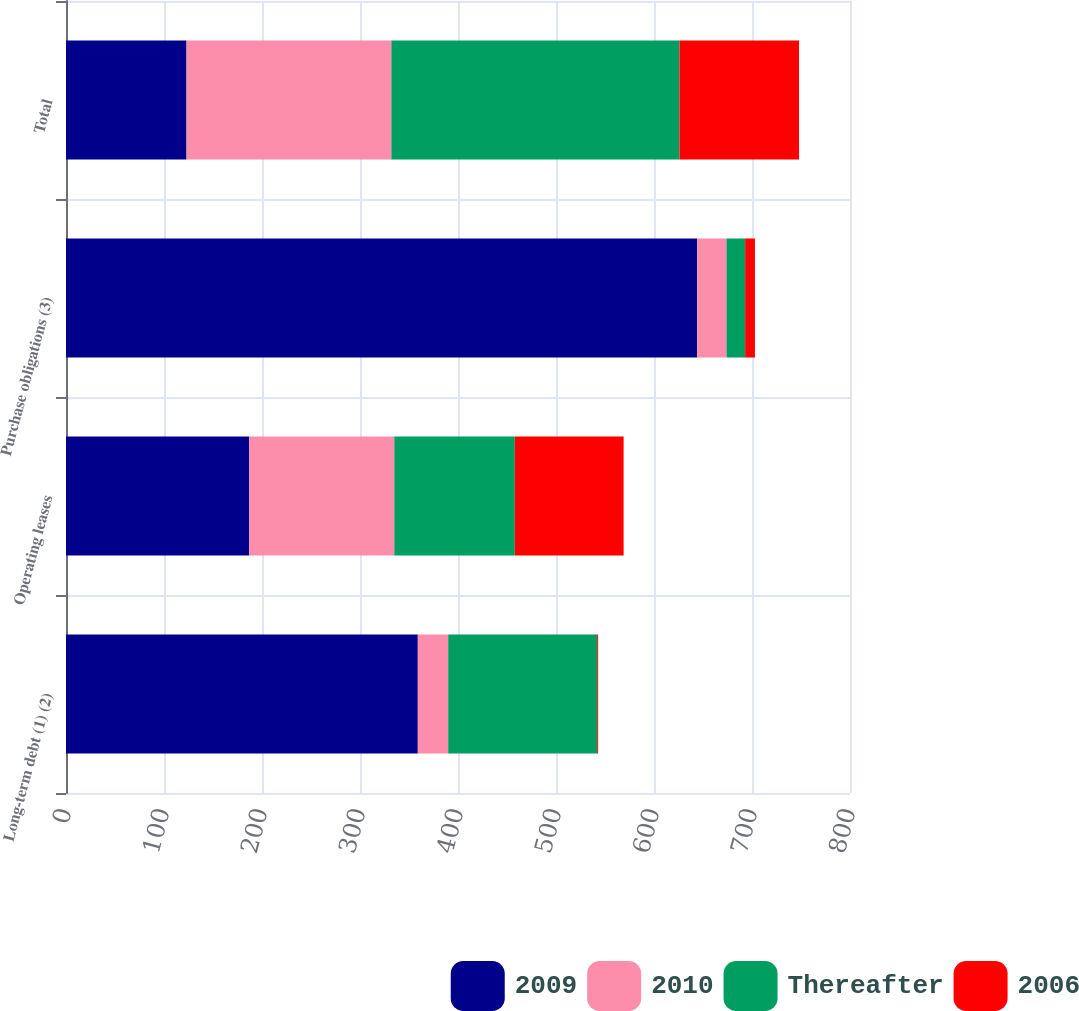Convert chart. <chart><loc_0><loc_0><loc_500><loc_500><stacked_bar_chart><ecel><fcel>Long-term debt (1) (2)<fcel>Operating leases<fcel>Purchase obligations (3)<fcel>Total<nl><fcel>2009<fcel>359<fcel>187<fcel>644<fcel>123<nl><fcel>2010<fcel>31<fcel>148<fcel>30<fcel>209<nl><fcel>Thereafter<fcel>152<fcel>123<fcel>19<fcel>294<nl><fcel>2006<fcel>1<fcel>111<fcel>10<fcel>122<nl></chart> 